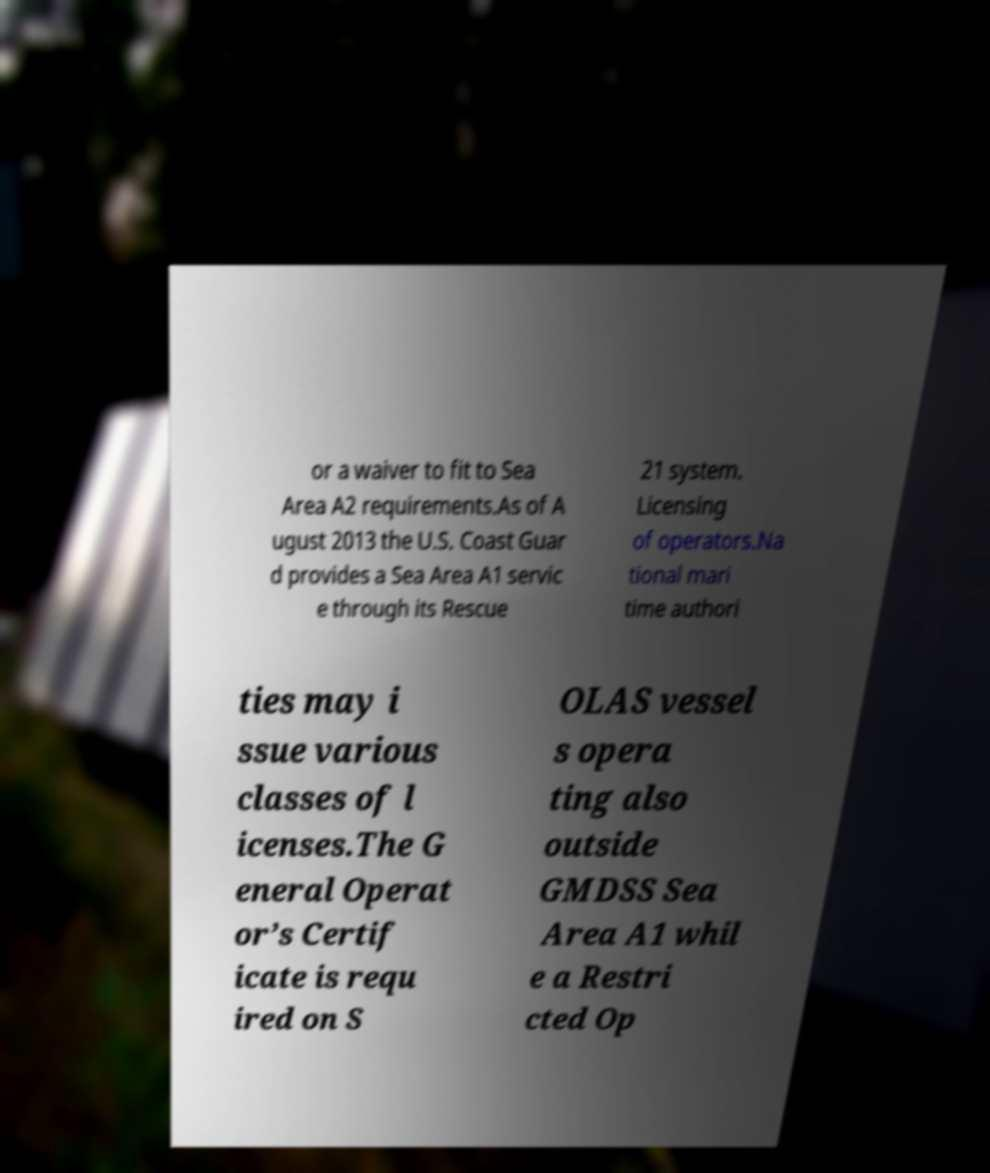Please read and relay the text visible in this image. What does it say? or a waiver to fit to Sea Area A2 requirements.As of A ugust 2013 the U.S. Coast Guar d provides a Sea Area A1 servic e through its Rescue 21 system. Licensing of operators.Na tional mari time authori ties may i ssue various classes of l icenses.The G eneral Operat or’s Certif icate is requ ired on S OLAS vessel s opera ting also outside GMDSS Sea Area A1 whil e a Restri cted Op 